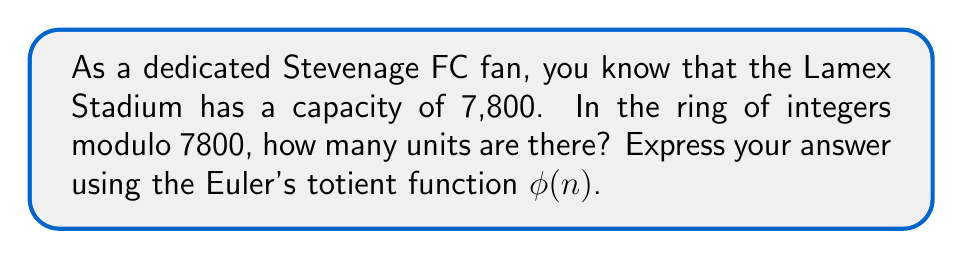Solve this math problem. Let's approach this step-by-step:

1) In a ring of integers modulo n, a unit is an element that has a multiplicative inverse.

2) An element a is a unit in ℤ/nℤ if and only if gcd(a,n) = 1.

3) The number of units in ℤ/nℤ is given by Euler's totient function φ(n).

4) For our case, n = 7800.

5) To calculate φ(7800), we need to factor 7800:
   7800 = 2³ × 3 × 5² × 13

6) For a prime power p^k, φ(p^k) = p^k - p^(k-1)

7) Using the multiplicative property of φ for coprime numbers:
   
   φ(7800) = φ(2³) × φ(3) × φ(5²) × φ(13)

8) Now, let's calculate each part:
   φ(2³) = 2³ - 2² = 8 - 4 = 4
   φ(3) = 3 - 1 = 2
   φ(5²) = 5² - 5 = 25 - 5 = 20
   φ(13) = 13 - 1 = 12

9) Multiplying these together:
   φ(7800) = 4 × 2 × 20 × 12 = 1920

Therefore, there are 1920 units in the ring of integers modulo 7800.
Answer: $\phi(7800) = 1920$ 